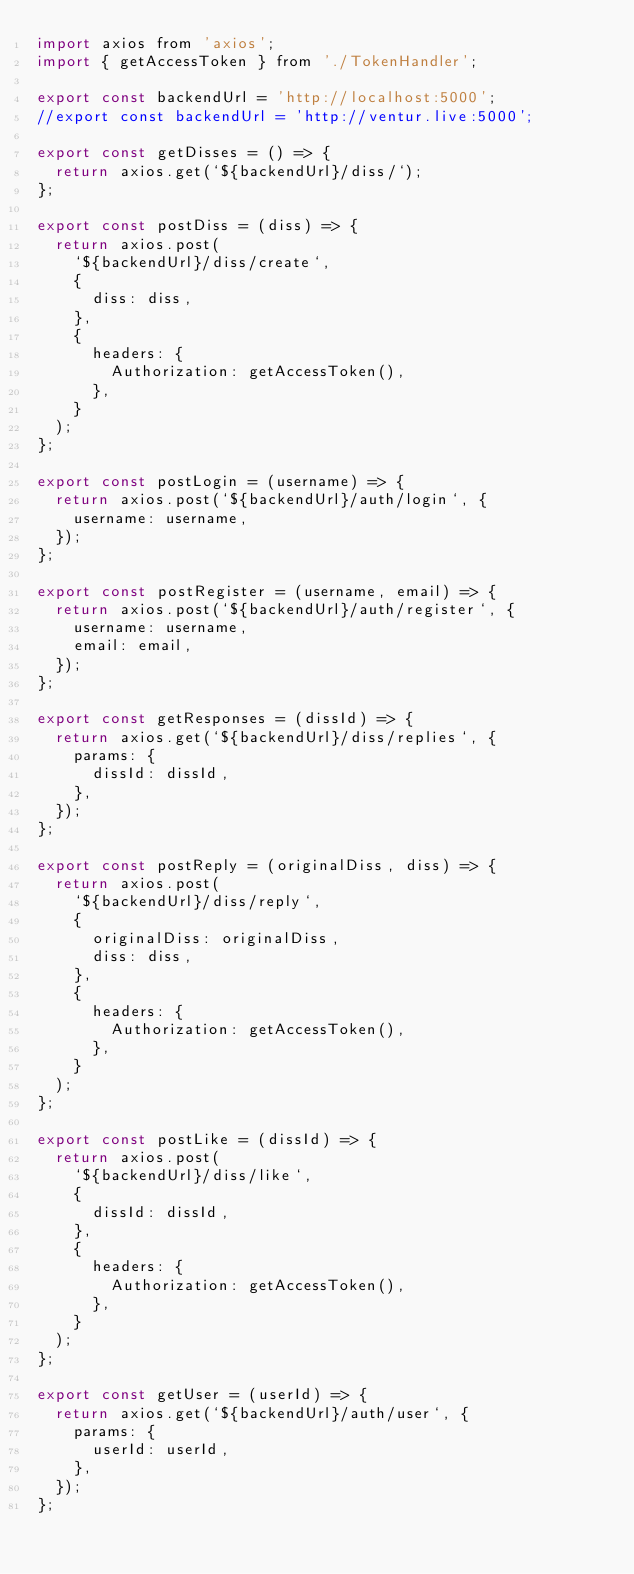<code> <loc_0><loc_0><loc_500><loc_500><_JavaScript_>import axios from 'axios';
import { getAccessToken } from './TokenHandler';

export const backendUrl = 'http://localhost:5000';
//export const backendUrl = 'http://ventur.live:5000';

export const getDisses = () => {
  return axios.get(`${backendUrl}/diss/`);
};

export const postDiss = (diss) => {
  return axios.post(
    `${backendUrl}/diss/create`,
    {
      diss: diss,
    },
    {
      headers: {
        Authorization: getAccessToken(),
      },
    }
  );
};

export const postLogin = (username) => {
  return axios.post(`${backendUrl}/auth/login`, {
    username: username,
  });
};

export const postRegister = (username, email) => {
  return axios.post(`${backendUrl}/auth/register`, {
    username: username,
    email: email,
  });
};

export const getResponses = (dissId) => {
  return axios.get(`${backendUrl}/diss/replies`, {
    params: {
      dissId: dissId,
    },
  });
};

export const postReply = (originalDiss, diss) => {
  return axios.post(
    `${backendUrl}/diss/reply`,
    {
      originalDiss: originalDiss,
      diss: diss,
    },
    {
      headers: {
        Authorization: getAccessToken(),
      },
    }
  );
};

export const postLike = (dissId) => {
  return axios.post(
    `${backendUrl}/diss/like`,
    {
      dissId: dissId,
    },
    {
      headers: {
        Authorization: getAccessToken(),
      },
    }
  );
};

export const getUser = (userId) => {
  return axios.get(`${backendUrl}/auth/user`, {
    params: {
      userId: userId,
    },
  });
};
</code> 